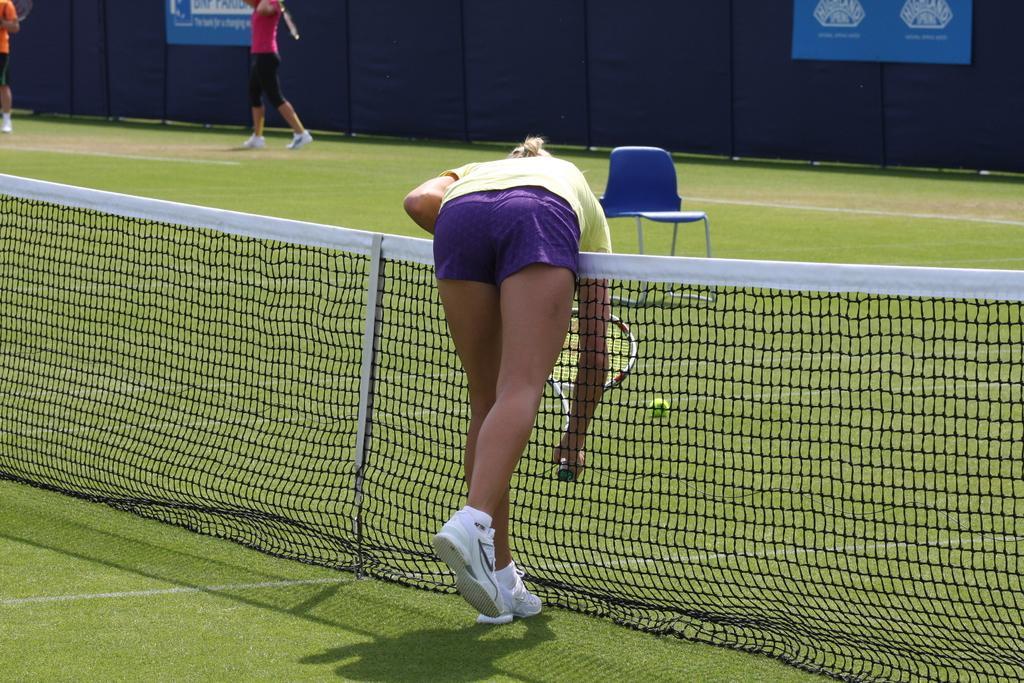Describe this image in one or two sentences. In this picture, we can see a few people holding an object, we can see the ground with some objects on it like a ball, net and a chair, the ground is covered with grass, and we can see the wall with posters. 